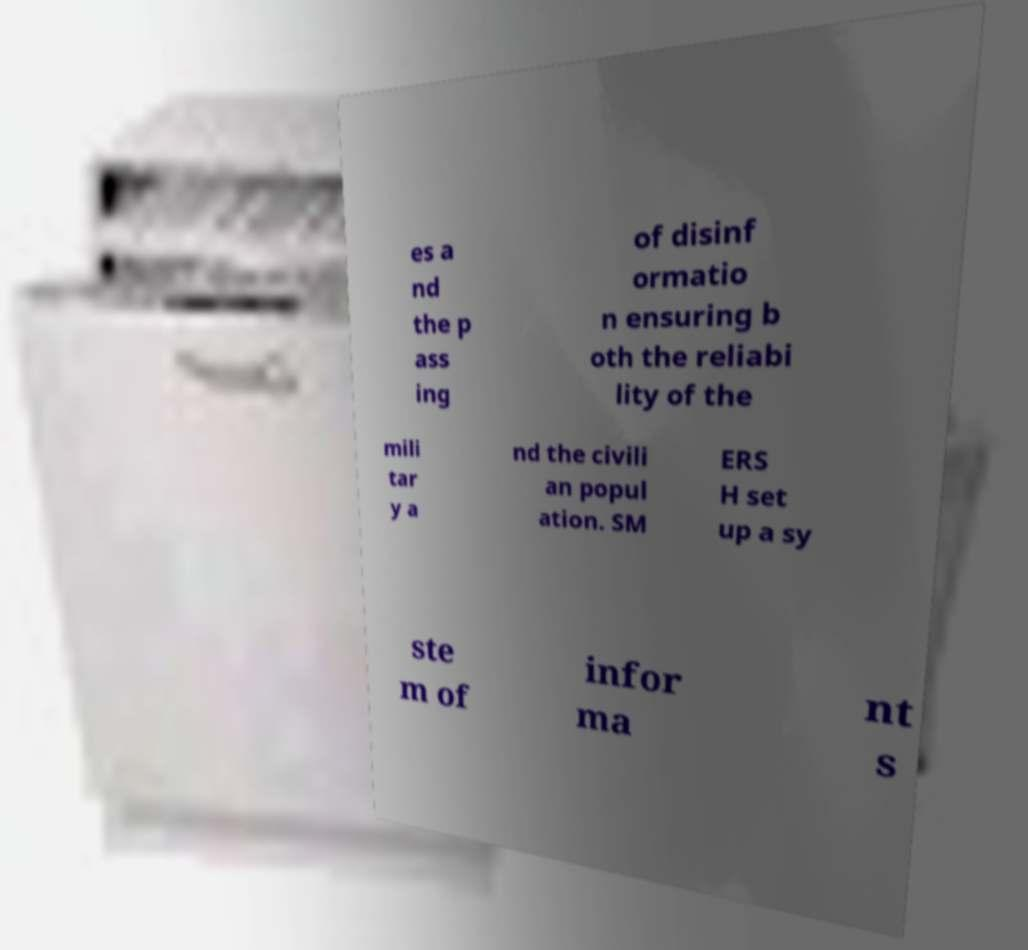There's text embedded in this image that I need extracted. Can you transcribe it verbatim? es a nd the p ass ing of disinf ormatio n ensuring b oth the reliabi lity of the mili tar y a nd the civili an popul ation. SM ERS H set up a sy ste m of infor ma nt s 